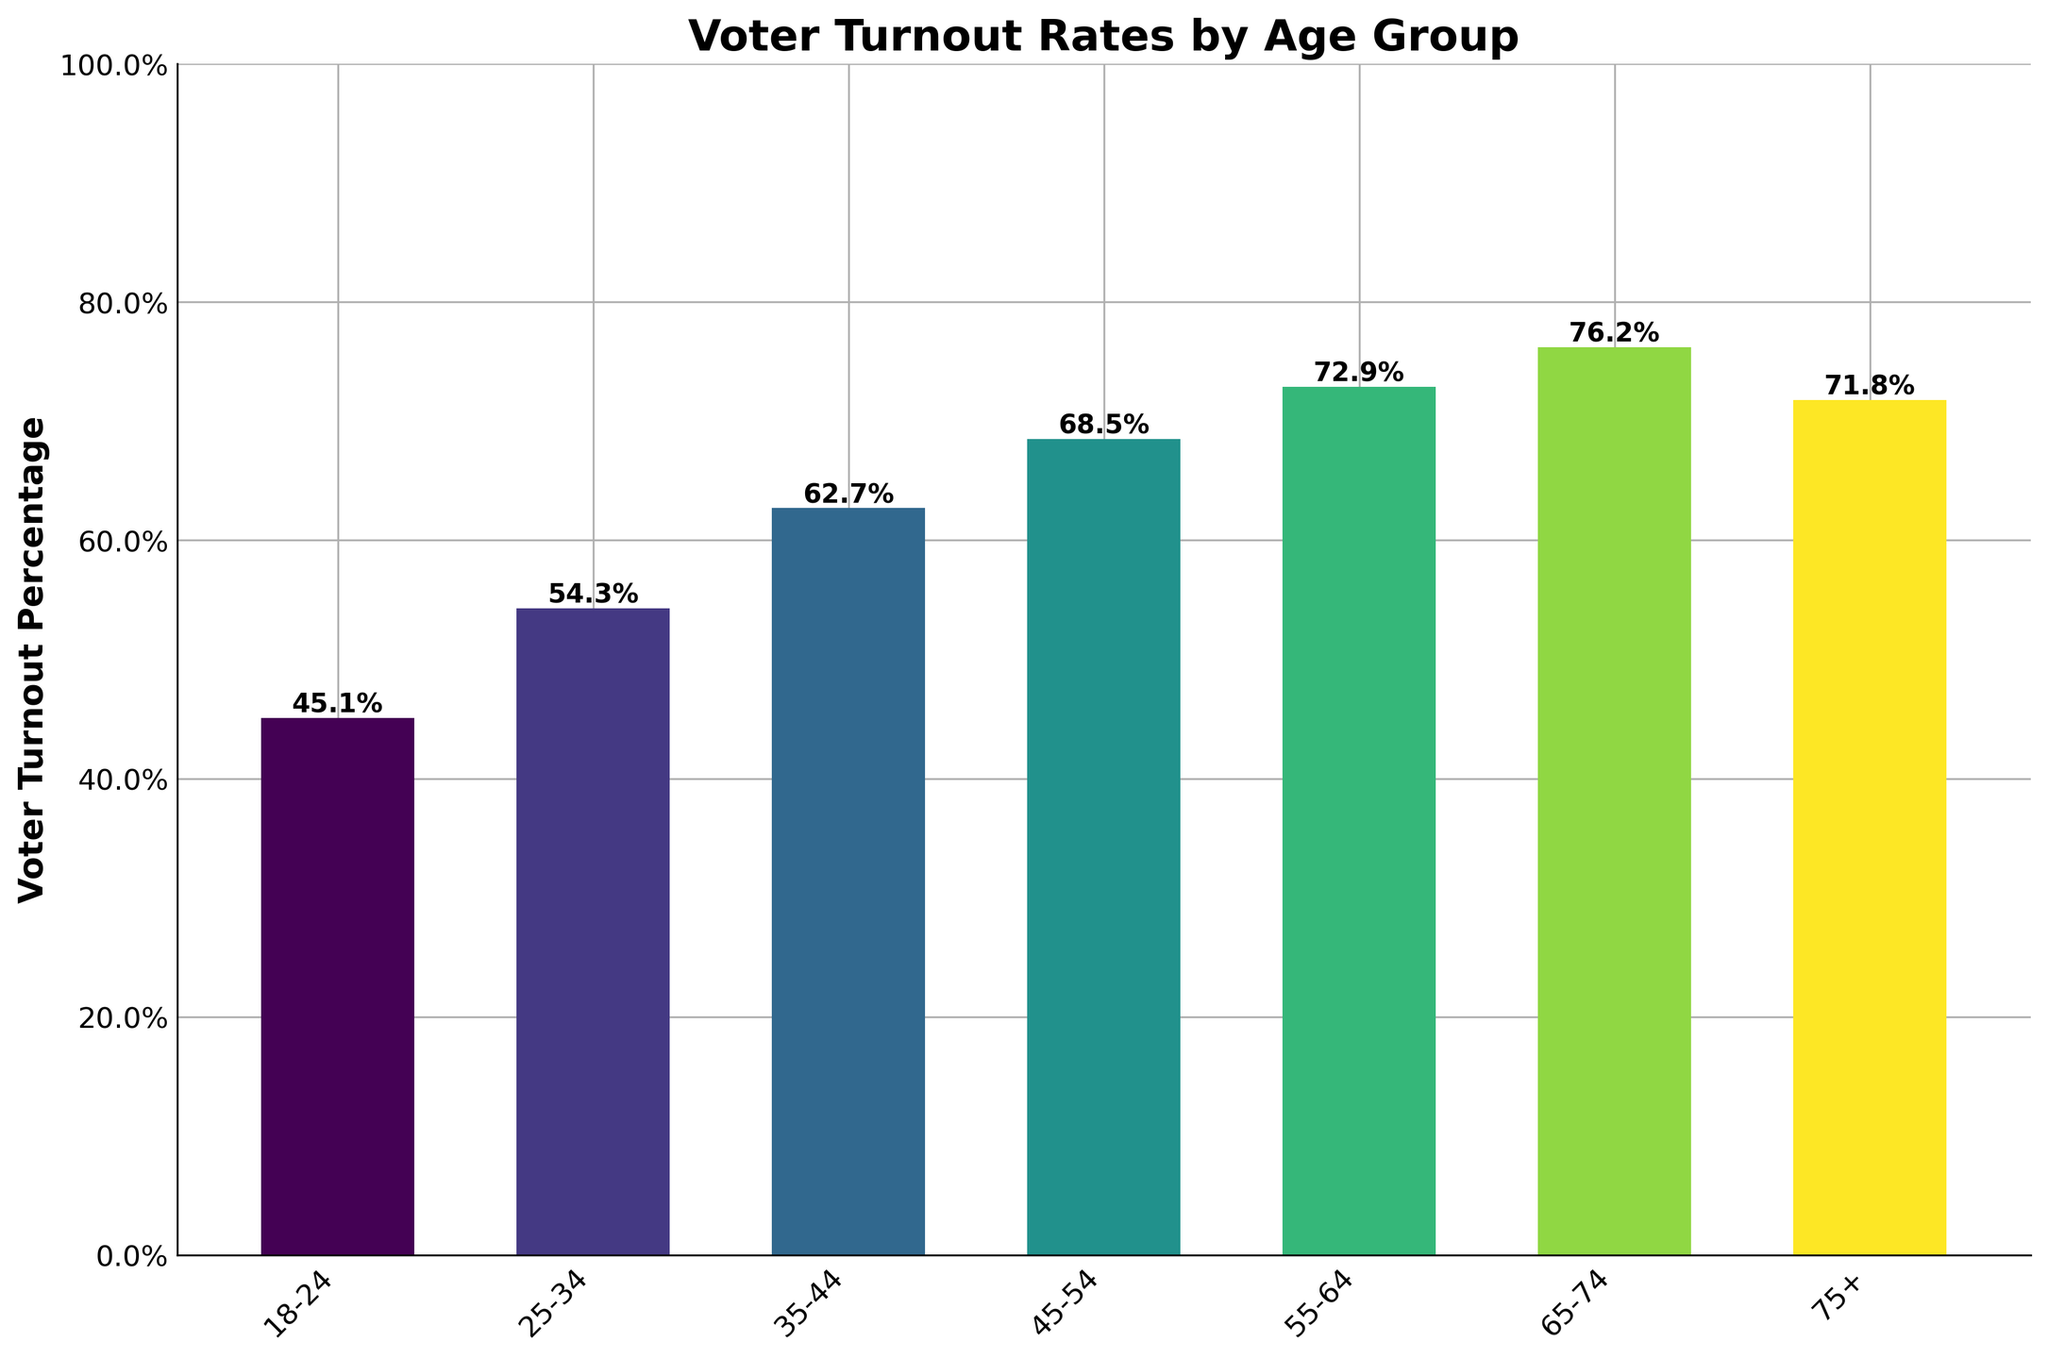What is the voter turnout percentage for the age group 65-74? Look at the bar associated with the age group 65-74 and read the height. The bar reaches 76.2%, which is also labeled on top of the bar.
Answer: 76.2% Which age group has the lowest voter turnout percentage? Compare the heights of all the bars to see which one is the shortest. The shortest bar corresponds to the age group 18-24, which has a voter turnout percentage of 45.1%.
Answer: 18-24 How many age groups have a turnout percentage over 70%? Identify the bars with heights above 70%. The bars associated with age groups 55-64, 65-74, and 75+ are all above 70%. Count these bars to find the total.
Answer: 3 What's the difference in voter turnout between the age groups 18-24 and 55-64? Subtract the voter turnout percentage of the age group 18-24 from that of 55-64. \( 72.9\% - 45.1\% = 27.8\% \).
Answer: 27.8% Which age group has a higher voter turnout, 25-34 or 35-44? Compare the heights of the bars for the age groups 25-34 and 35-44. The bar for 35-44 (62.7%) is higher than the bar for 25-34 (54.3%).
Answer: 35-44 By how much does the voter turnout percentage increase from the age group 25-34 to 45-54? Subtract the voter turnout percentage of the age group 25-34 from that of 45-54. \( 68.5\% - 54.3\% = 14.2\% \).
Answer: 14.2% What is the average voter turnout percentage for the age groups 45-54, 55-64, and 65-74? Add the voter turnout percentages for the age groups 45-54, 55-64, and 65-74, and then divide by 3. \( \frac{68.5\% + 72.9\% + 76.2\%}{3} = 72.53\%\).
Answer: 72.53% Is there an age group with a voter turnout percentage between 60% and 70%? Look at the bars to identify any that fall within the range of 60% to 70%. The bar for the age group 35-44 (62.7%) falls within this range.
Answer: Yes Which age group shows the greatest increase in voter turnout percentage compared to the previous one? Calculate the differences between consecutive age groups and identify which is the greatest. Differences: \( 54.3\% - 45.1\% = 9.2\% \), \( 62.7\% - 54.3\% = 8.4\% \), \( 68.5\% - 62.7\% = 5.8\% \), \( 72.9\% - 68.5\% = 4.4\% \), \( 76.2\% - 72.9\% = 3.3\% \), \( 71.8\% - 76.2\% = -4.4\% \). The greatest increase of 9.2% is from 18-24 to 25-34.
Answer: 18-24 to 25-34 Which age group has a turnout percentage closest to 75%? Compare each age group's turnout percentage to 75% and identify which is closest. The age group 65-74 has a turnout of 76.2%, which is closest to 75%.
Answer: 65-74 